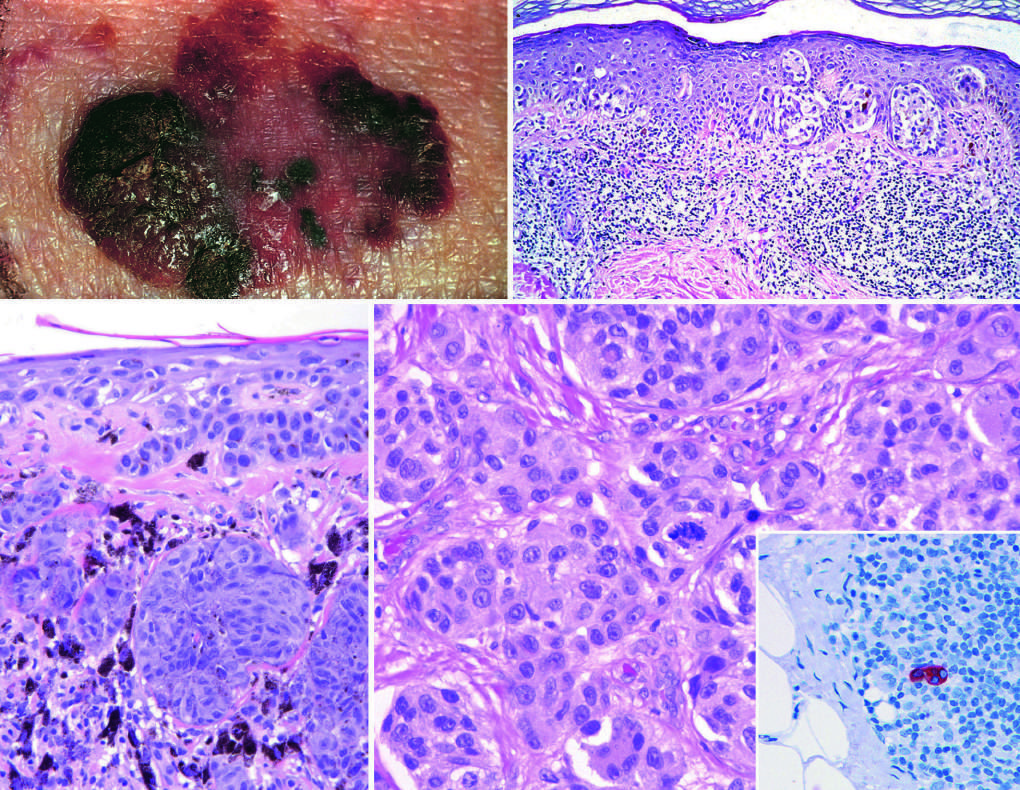does the cut liver section, in which major blood vessels are visible, indicate dermal invasion vertical growth?
Answer the question using a single word or phrase. No 